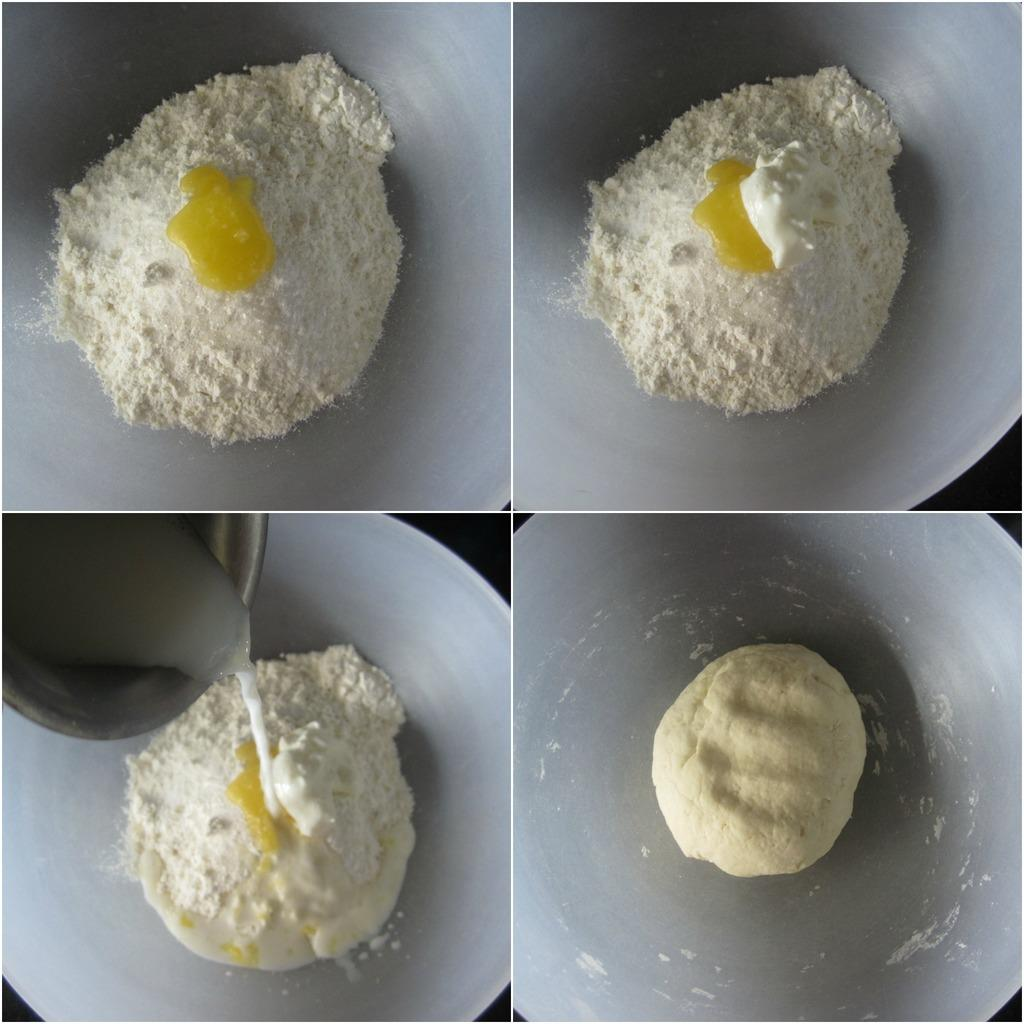What type of photos can be seen in the image? There are college photos in the image. What ingredient is visible in the image? There is flour visible in the image. What substance is present in a liquid state in the image? There is liquid visible in the image. What is being made with the ingredients and liquid in the image? There is a dough visible in the image. What type of gold object is visible in the image? There is no gold object present in the image. How many mittens are visible in the image? There are no mittens present in the image. What arithmetic problem is being solved in the image? There is no arithmetic problem visible in the image. 